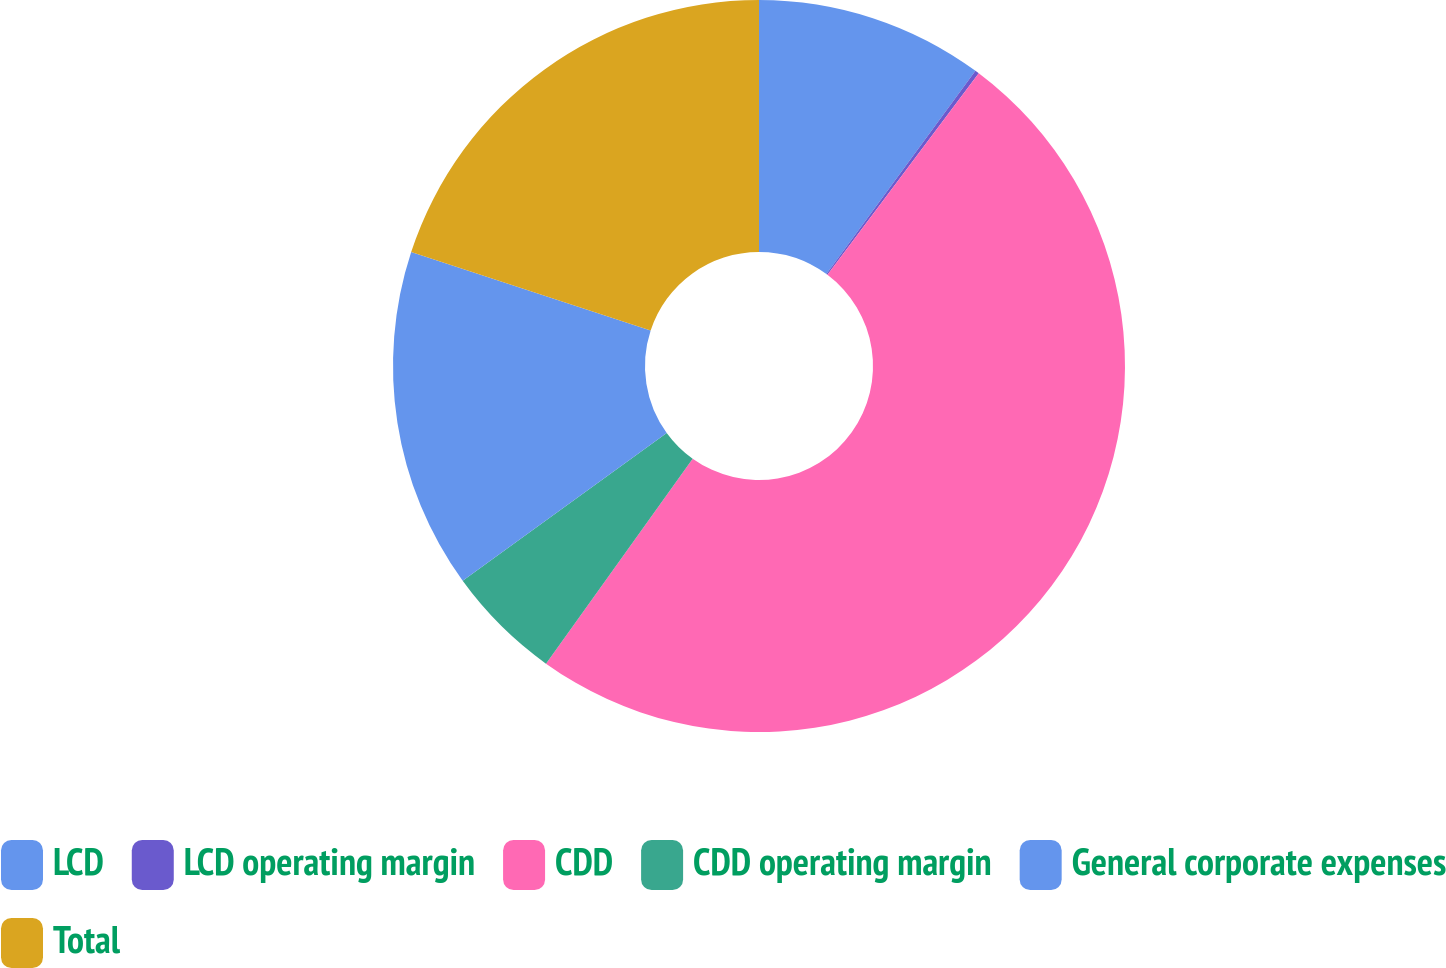Convert chart. <chart><loc_0><loc_0><loc_500><loc_500><pie_chart><fcel>LCD<fcel>LCD operating margin<fcel>CDD<fcel>CDD operating margin<fcel>General corporate expenses<fcel>Total<nl><fcel>10.07%<fcel>0.18%<fcel>49.63%<fcel>5.13%<fcel>15.02%<fcel>19.96%<nl></chart> 